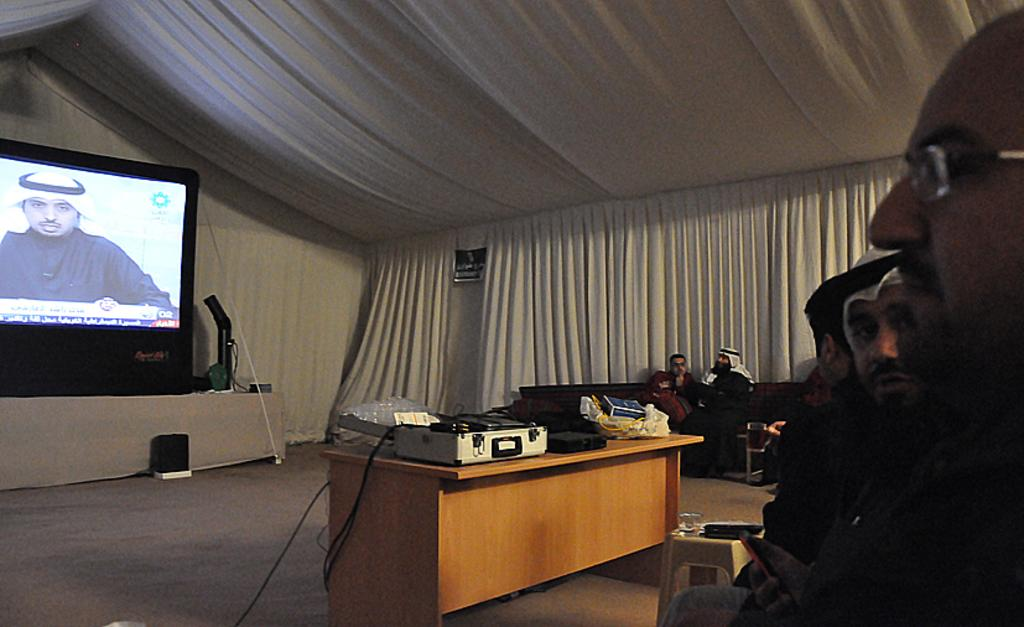What electronic device is present in the image? There is a television in the image. What are the people in the image doing? The people in the image are sitting. What can be seen on the table in the image? There are items on a table in the image. What type of setting is depicted in the image? The setting appears to be a tent. What audio device is located on the floor in the image? There is a speaker on the floor in the image. What type of quiver is visible in the image? There is no quiver present in the image. What force is being applied to the television in the image? There is no force being applied to the television in the image; it is stationary. 